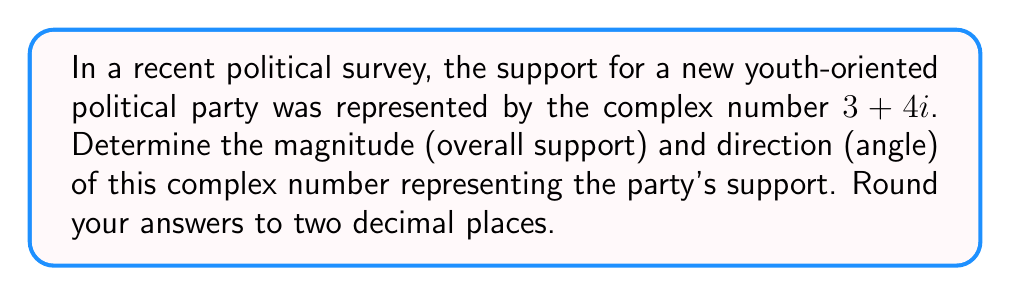Solve this math problem. To solve this problem, we need to convert the complex number from rectangular form $(a + bi)$ to polar form $(r(\cos\theta + i\sin\theta))$.

1. Calculate the magnitude (r):
   The magnitude is given by the formula: $r = \sqrt{a^2 + b^2}$
   Here, $a = 3$ and $b = 4$
   $$r = \sqrt{3^2 + 4^2} = \sqrt{9 + 16} = \sqrt{25} = 5$$

2. Calculate the direction (θ):
   The direction is given by the formula: $\theta = \tan^{-1}(\frac{b}{a})$
   $$\theta = \tan^{-1}(\frac{4}{3})$$
   Using a calculator: $\theta \approx 0.9273$ radians

3. Convert radians to degrees:
   $$\theta_{degrees} = \theta_{radians} \times \frac{180°}{\pi}$$
   $$\theta_{degrees} \approx 0.9273 \times \frac{180°}{\pi} \approx 53.13°$$

The magnitude represents the overall support for the party, while the angle represents the direction or focus of the support in the political spectrum.
Answer: Magnitude: 5.00
Direction: 53.13° 